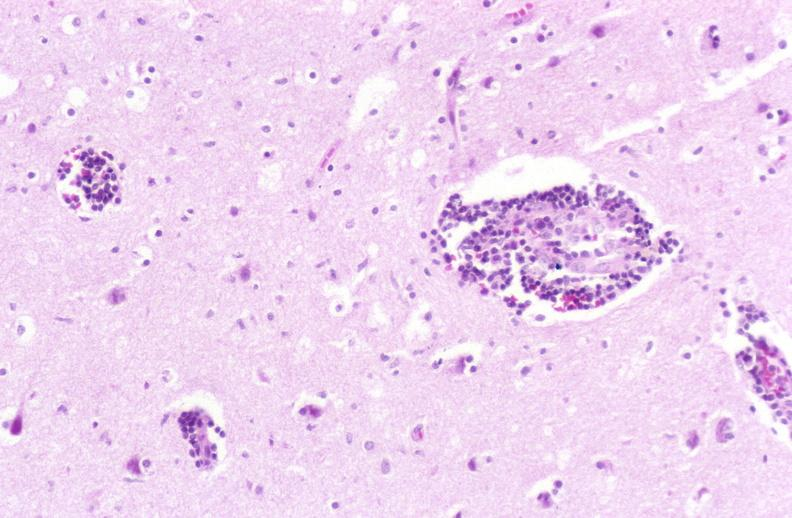s nervous present?
Answer the question using a single word or phrase. Yes 